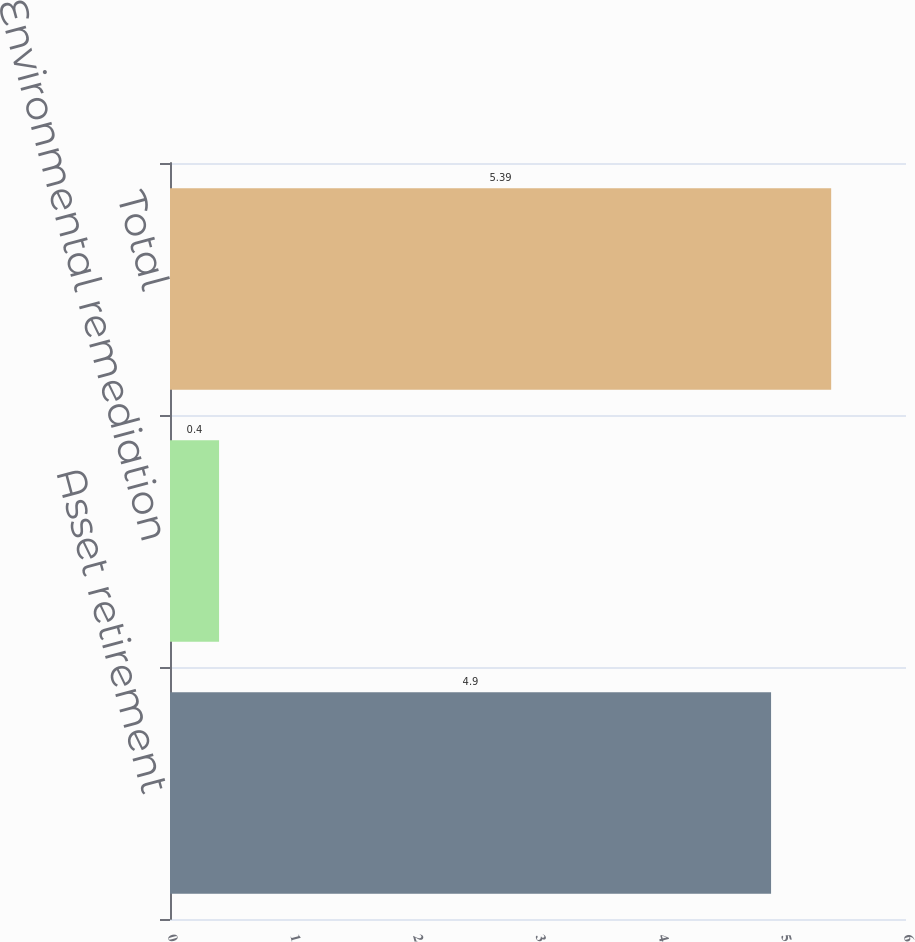Convert chart. <chart><loc_0><loc_0><loc_500><loc_500><bar_chart><fcel>Asset retirement<fcel>Environmental remediation<fcel>Total<nl><fcel>4.9<fcel>0.4<fcel>5.39<nl></chart> 